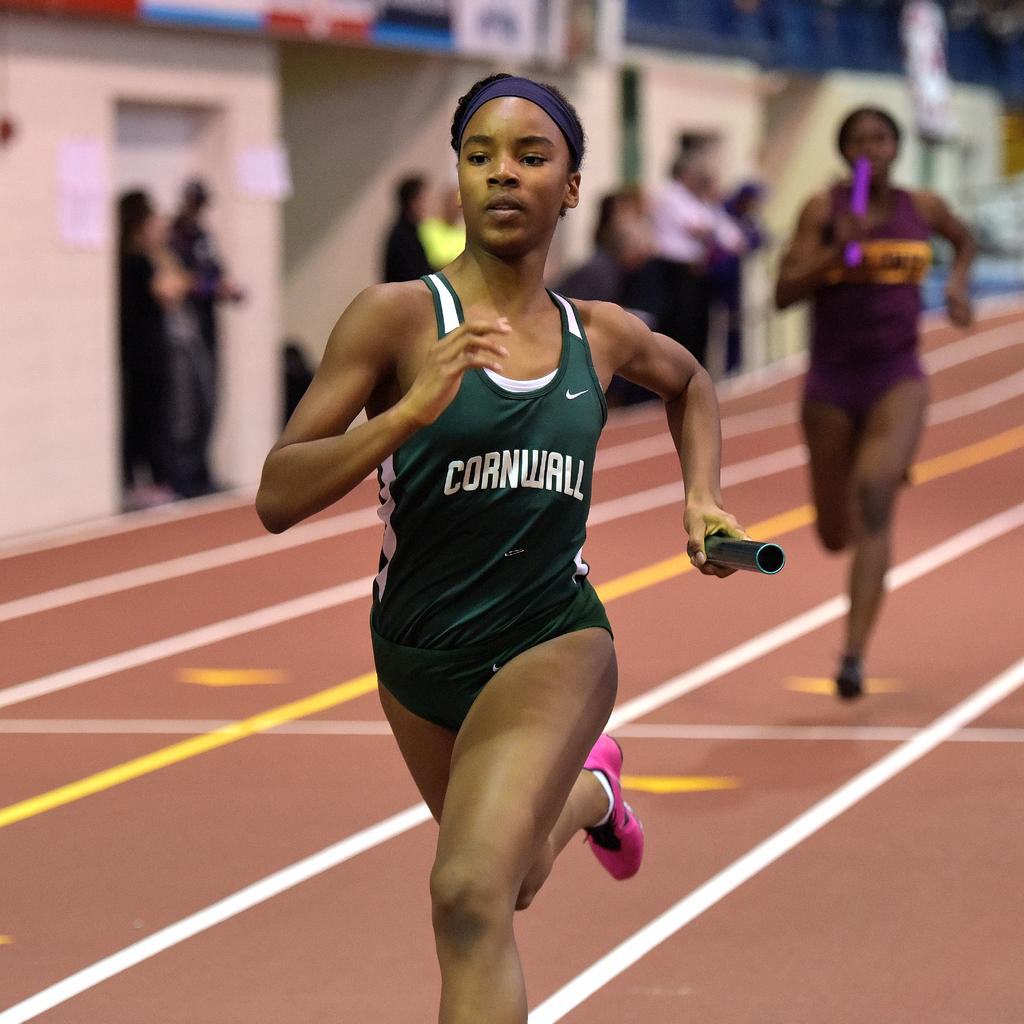Who is the main subject in the image? There is a woman in the image. What is the woman doing in the image? The woman is running on the ground. Are there any other people in the image? Yes, there are other people behind the woman. How is the background of the woman depicted in the image? The background of the woman is blurred. What type of machine is the woman operating in the image? There is no machine present in the image; the woman is running on the ground. What emotion does the woman express towards the other people in the image? The image does not convey any specific emotion or interaction between the woman and the other people, so it is not possible to determine her feelings towards them. 